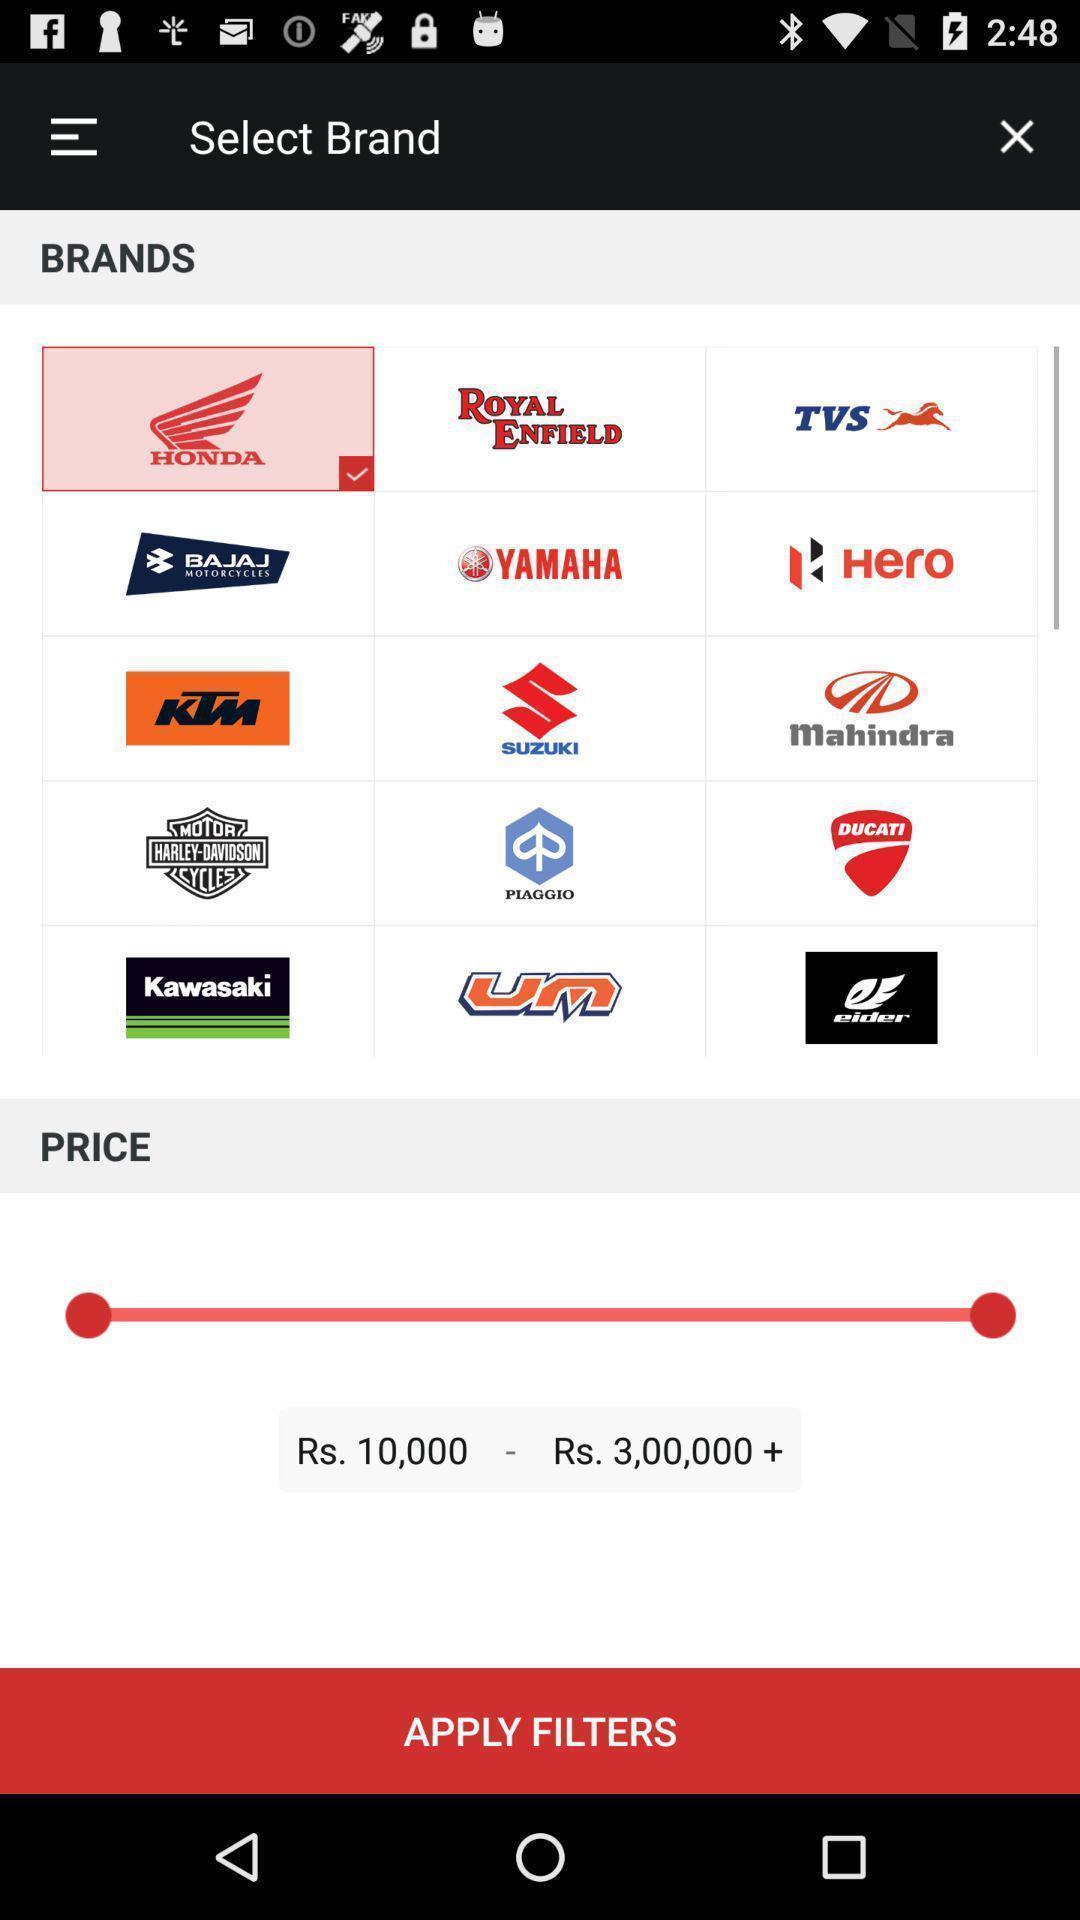Please provide a description for this image. Screen displaying multiple vehicle logos. 